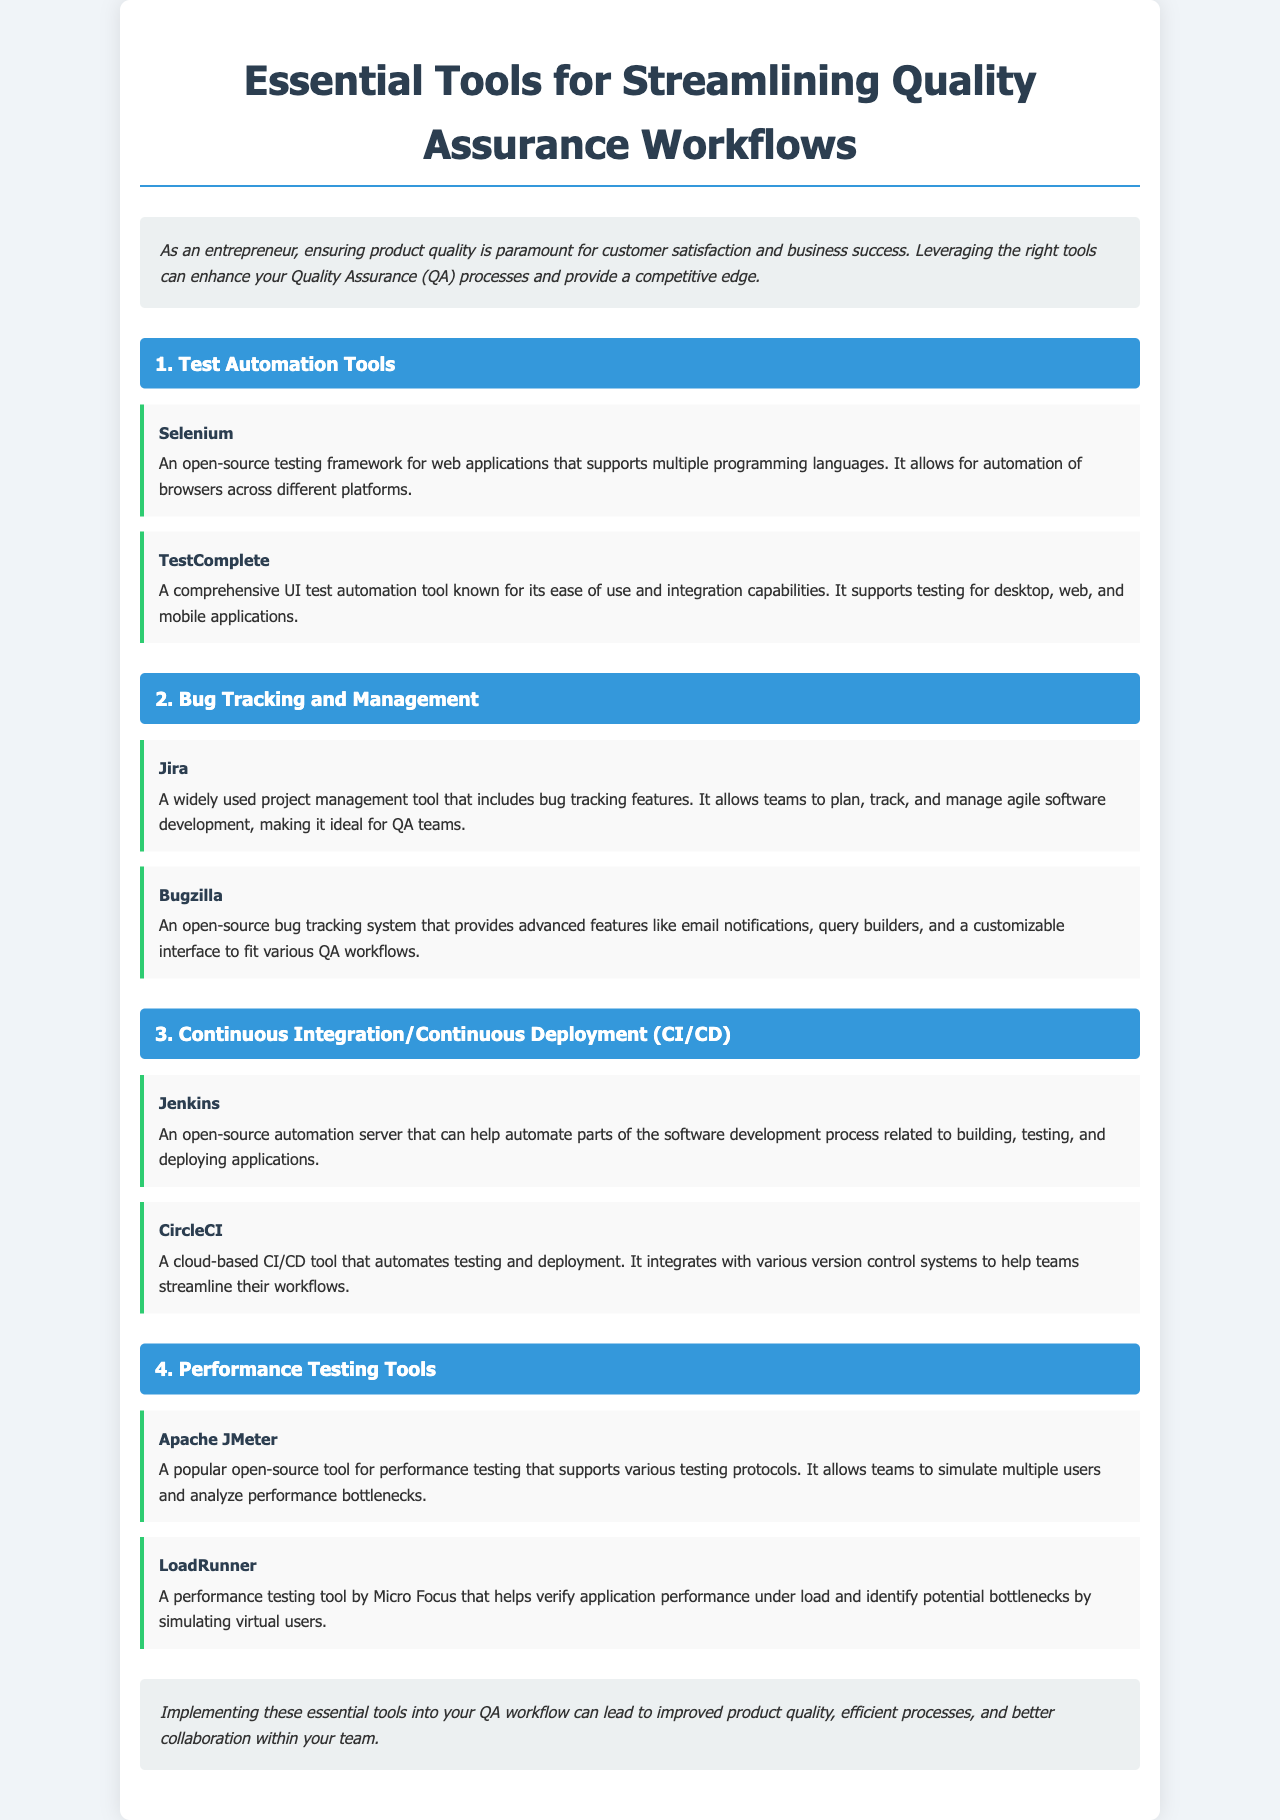What is the title of the document? The title of the document is prominently displayed at the top of the brochure.
Answer: Essential Tools for Streamlining Quality Assurance Workflows What tool is known for its ease of use and integration capabilities? This information can be found in the section about Test Automation Tools.
Answer: TestComplete What type of tool is Jira? Jira is categorized in the Bug Tracking and Management section of the document.
Answer: Project management tool How many tools are listed in the Performance Testing Tools section? The document provides information on the tools in each section, including the number of tools.
Answer: 2 What is the main benefit of implementing essential tools into the QA workflow? The conclusion of the document summarizes this key benefit.
Answer: Improved product quality Which testing tool supports multiple programming languages? The specific tool is mentioned in the Test Automation Tools section.
Answer: Selenium What does Jenkins help automate? The document details Jenkins' capabilities in its respective section.
Answer: Software development process Which tool is described as a cloud-based CI/CD tool? This information is provided in the Continuous Integration/Continuous Deployment section.
Answer: CircleCI 